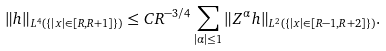Convert formula to latex. <formula><loc_0><loc_0><loc_500><loc_500>\| h \| _ { L ^ { 4 } ( \{ | x | \in [ R , R + 1 ] \} ) } \leq C R ^ { - 3 / 4 } \sum _ { | \alpha | \leq 1 } \| Z ^ { \alpha } h \| _ { L ^ { 2 } ( \{ | x | \in [ R - 1 , R + 2 ] \} ) } .</formula> 